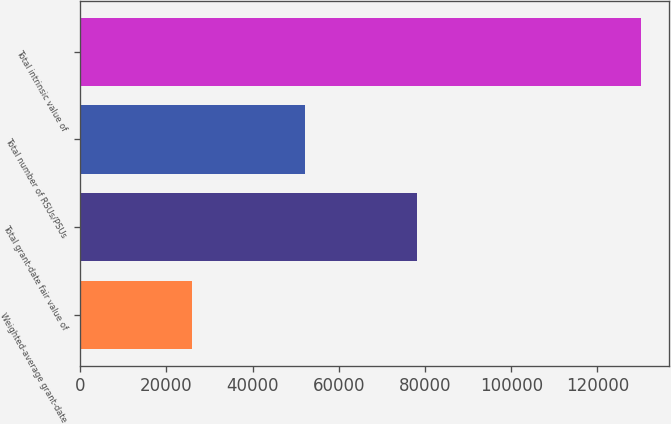<chart> <loc_0><loc_0><loc_500><loc_500><bar_chart><fcel>Weighted-average grant-date<fcel>Total grant-date fair value of<fcel>Total number of RSUs/PSUs<fcel>Total intrinsic value of<nl><fcel>26037.5<fcel>78093<fcel>52065.2<fcel>130148<nl></chart> 